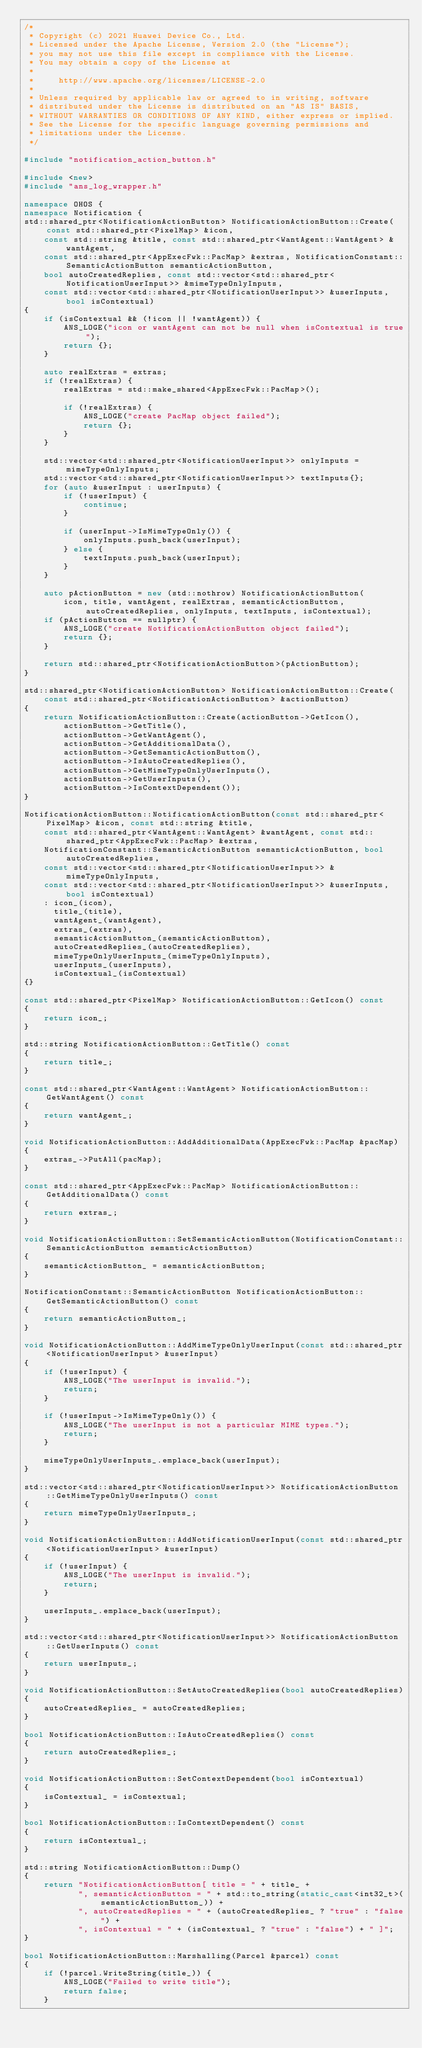<code> <loc_0><loc_0><loc_500><loc_500><_C++_>/*
 * Copyright (c) 2021 Huawei Device Co., Ltd.
 * Licensed under the Apache License, Version 2.0 (the "License");
 * you may not use this file except in compliance with the License.
 * You may obtain a copy of the License at
 *
 *     http://www.apache.org/licenses/LICENSE-2.0
 *
 * Unless required by applicable law or agreed to in writing, software
 * distributed under the License is distributed on an "AS IS" BASIS,
 * WITHOUT WARRANTIES OR CONDITIONS OF ANY KIND, either express or implied.
 * See the License for the specific language governing permissions and
 * limitations under the License.
 */

#include "notification_action_button.h"

#include <new>
#include "ans_log_wrapper.h"

namespace OHOS {
namespace Notification {
std::shared_ptr<NotificationActionButton> NotificationActionButton::Create(const std::shared_ptr<PixelMap> &icon,
    const std::string &title, const std::shared_ptr<WantAgent::WantAgent> &wantAgent,
    const std::shared_ptr<AppExecFwk::PacMap> &extras, NotificationConstant::SemanticActionButton semanticActionButton,
    bool autoCreatedReplies, const std::vector<std::shared_ptr<NotificationUserInput>> &mimeTypeOnlyInputs,
    const std::vector<std::shared_ptr<NotificationUserInput>> &userInputs, bool isContextual)
{
    if (isContextual && (!icon || !wantAgent)) {
        ANS_LOGE("icon or wantAgent can not be null when isContextual is true");
        return {};
    }

    auto realExtras = extras;
    if (!realExtras) {
        realExtras = std::make_shared<AppExecFwk::PacMap>();

        if (!realExtras) {
            ANS_LOGE("create PacMap object failed");
            return {};
        }
    }

    std::vector<std::shared_ptr<NotificationUserInput>> onlyInputs = mimeTypeOnlyInputs;
    std::vector<std::shared_ptr<NotificationUserInput>> textInputs{};
    for (auto &userInput : userInputs) {
        if (!userInput) {
            continue;
        }

        if (userInput->IsMimeTypeOnly()) {
            onlyInputs.push_back(userInput);
        } else {
            textInputs.push_back(userInput);
        }
    }

    auto pActionButton = new (std::nothrow) NotificationActionButton(
        icon, title, wantAgent, realExtras, semanticActionButton, autoCreatedReplies, onlyInputs, textInputs, isContextual);
    if (pActionButton == nullptr) {
        ANS_LOGE("create NotificationActionButton object failed");
        return {};
    }

    return std::shared_ptr<NotificationActionButton>(pActionButton);
}

std::shared_ptr<NotificationActionButton> NotificationActionButton::Create(
    const std::shared_ptr<NotificationActionButton> &actionButton)
{
    return NotificationActionButton::Create(actionButton->GetIcon(),
        actionButton->GetTitle(),
        actionButton->GetWantAgent(),
        actionButton->GetAdditionalData(),
        actionButton->GetSemanticActionButton(),
        actionButton->IsAutoCreatedReplies(),
        actionButton->GetMimeTypeOnlyUserInputs(),
        actionButton->GetUserInputs(),
        actionButton->IsContextDependent());
}

NotificationActionButton::NotificationActionButton(const std::shared_ptr<PixelMap> &icon, const std::string &title,
    const std::shared_ptr<WantAgent::WantAgent> &wantAgent, const std::shared_ptr<AppExecFwk::PacMap> &extras,
    NotificationConstant::SemanticActionButton semanticActionButton, bool autoCreatedReplies,
    const std::vector<std::shared_ptr<NotificationUserInput>> &mimeTypeOnlyInputs,
    const std::vector<std::shared_ptr<NotificationUserInput>> &userInputs, bool isContextual)
    : icon_(icon),
      title_(title),
      wantAgent_(wantAgent),
      extras_(extras),
      semanticActionButton_(semanticActionButton),
      autoCreatedReplies_(autoCreatedReplies),
      mimeTypeOnlyUserInputs_(mimeTypeOnlyInputs),
      userInputs_(userInputs),
      isContextual_(isContextual)
{}

const std::shared_ptr<PixelMap> NotificationActionButton::GetIcon() const
{
    return icon_;
}

std::string NotificationActionButton::GetTitle() const
{
    return title_;
}

const std::shared_ptr<WantAgent::WantAgent> NotificationActionButton::GetWantAgent() const
{
    return wantAgent_;
}

void NotificationActionButton::AddAdditionalData(AppExecFwk::PacMap &pacMap)
{
    extras_->PutAll(pacMap);
}

const std::shared_ptr<AppExecFwk::PacMap> NotificationActionButton::GetAdditionalData() const
{
    return extras_;
}

void NotificationActionButton::SetSemanticActionButton(NotificationConstant::SemanticActionButton semanticActionButton)
{
    semanticActionButton_ = semanticActionButton;
}

NotificationConstant::SemanticActionButton NotificationActionButton::GetSemanticActionButton() const
{
    return semanticActionButton_;
}

void NotificationActionButton::AddMimeTypeOnlyUserInput(const std::shared_ptr<NotificationUserInput> &userInput)
{
    if (!userInput) {
        ANS_LOGE("The userInput is invalid.");
        return;
    }

    if (!userInput->IsMimeTypeOnly()) {
        ANS_LOGE("The userInput is not a particular MIME types.");
        return;
    }

    mimeTypeOnlyUserInputs_.emplace_back(userInput);
}

std::vector<std::shared_ptr<NotificationUserInput>> NotificationActionButton::GetMimeTypeOnlyUserInputs() const
{
    return mimeTypeOnlyUserInputs_;
}

void NotificationActionButton::AddNotificationUserInput(const std::shared_ptr<NotificationUserInput> &userInput)
{
    if (!userInput) {
        ANS_LOGE("The userInput is invalid.");
        return;
    }

    userInputs_.emplace_back(userInput);
}

std::vector<std::shared_ptr<NotificationUserInput>> NotificationActionButton::GetUserInputs() const
{
    return userInputs_;
}

void NotificationActionButton::SetAutoCreatedReplies(bool autoCreatedReplies)
{
    autoCreatedReplies_ = autoCreatedReplies;
}

bool NotificationActionButton::IsAutoCreatedReplies() const
{
    return autoCreatedReplies_;
}

void NotificationActionButton::SetContextDependent(bool isContextual)
{
    isContextual_ = isContextual;
}

bool NotificationActionButton::IsContextDependent() const
{
    return isContextual_;
}

std::string NotificationActionButton::Dump()
{
    return "NotificationActionButton[ title = " + title_ +
           ", semanticActionButton = " + std::to_string(static_cast<int32_t>(semanticActionButton_)) +
           ", autoCreatedReplies = " + (autoCreatedReplies_ ? "true" : "false") +
           ", isContextual = " + (isContextual_ ? "true" : "false") + " ]";
}

bool NotificationActionButton::Marshalling(Parcel &parcel) const
{
    if (!parcel.WriteString(title_)) {
        ANS_LOGE("Failed to write title");
        return false;
    }
</code> 